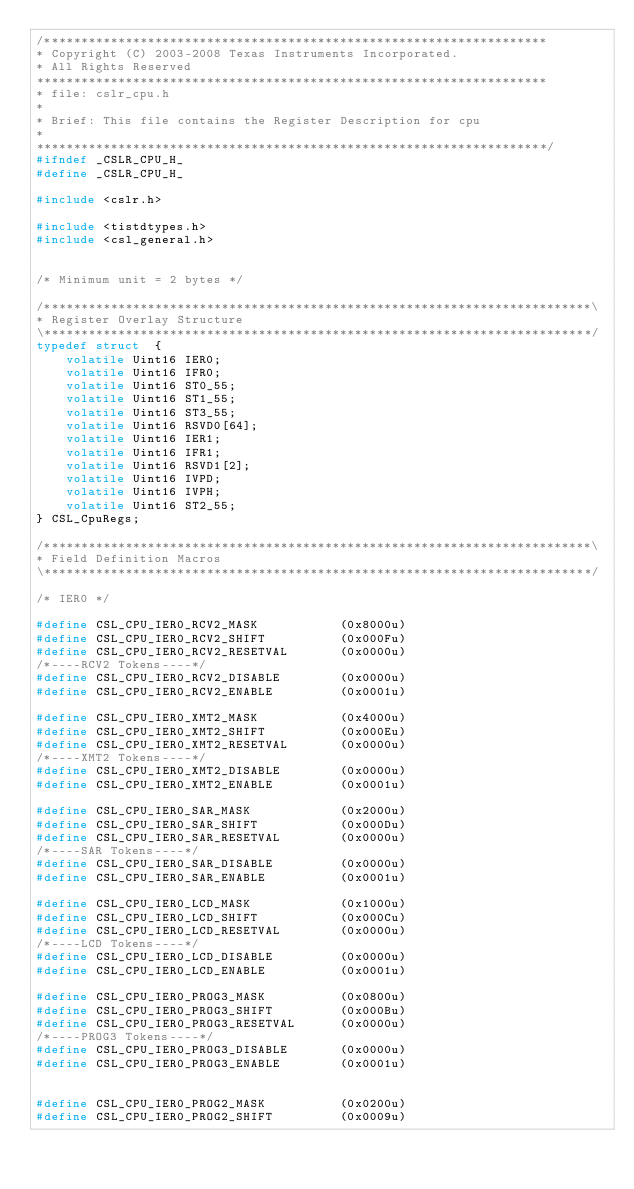Convert code to text. <code><loc_0><loc_0><loc_500><loc_500><_C_>/********************************************************************
* Copyright (C) 2003-2008 Texas Instruments Incorporated.
* All Rights Reserved
*********************************************************************
* file: cslr_cpu.h
*
* Brief: This file contains the Register Description for cpu
*
*********************************************************************/
#ifndef _CSLR_CPU_H_
#define _CSLR_CPU_H_

#include <cslr.h>

#include <tistdtypes.h>
#include <csl_general.h>


/* Minimum unit = 2 bytes */

/**************************************************************************\
* Register Overlay Structure
\**************************************************************************/
typedef struct  {
    volatile Uint16 IER0;
    volatile Uint16 IFR0;
    volatile Uint16 ST0_55;
    volatile Uint16 ST1_55;
    volatile Uint16 ST3_55;
    volatile Uint16 RSVD0[64];
    volatile Uint16 IER1;
    volatile Uint16 IFR1;
    volatile Uint16 RSVD1[2];
    volatile Uint16 IVPD;
    volatile Uint16 IVPH;
    volatile Uint16 ST2_55;
} CSL_CpuRegs;

/**************************************************************************\
* Field Definition Macros
\**************************************************************************/

/* IER0 */

#define CSL_CPU_IER0_RCV2_MASK           (0x8000u)
#define CSL_CPU_IER0_RCV2_SHIFT          (0x000Fu)
#define CSL_CPU_IER0_RCV2_RESETVAL       (0x0000u)
/*----RCV2 Tokens----*/
#define CSL_CPU_IER0_RCV2_DISABLE        (0x0000u)
#define CSL_CPU_IER0_RCV2_ENABLE         (0x0001u)

#define CSL_CPU_IER0_XMT2_MASK           (0x4000u)
#define CSL_CPU_IER0_XMT2_SHIFT          (0x000Eu)
#define CSL_CPU_IER0_XMT2_RESETVAL       (0x0000u)
/*----XMT2 Tokens----*/
#define CSL_CPU_IER0_XMT2_DISABLE        (0x0000u)
#define CSL_CPU_IER0_XMT2_ENABLE         (0x0001u)

#define CSL_CPU_IER0_SAR_MASK            (0x2000u)
#define CSL_CPU_IER0_SAR_SHIFT           (0x000Du)
#define CSL_CPU_IER0_SAR_RESETVAL        (0x0000u)
/*----SAR Tokens----*/
#define CSL_CPU_IER0_SAR_DISABLE         (0x0000u)
#define CSL_CPU_IER0_SAR_ENABLE          (0x0001u)

#define CSL_CPU_IER0_LCD_MASK            (0x1000u)
#define CSL_CPU_IER0_LCD_SHIFT           (0x000Cu)
#define CSL_CPU_IER0_LCD_RESETVAL        (0x0000u)
/*----LCD Tokens----*/
#define CSL_CPU_IER0_LCD_DISABLE         (0x0000u)
#define CSL_CPU_IER0_LCD_ENABLE          (0x0001u)

#define CSL_CPU_IER0_PROG3_MASK          (0x0800u)
#define CSL_CPU_IER0_PROG3_SHIFT         (0x000Bu)
#define CSL_CPU_IER0_PROG3_RESETVAL      (0x0000u)
/*----PROG3 Tokens----*/
#define CSL_CPU_IER0_PROG3_DISABLE       (0x0000u)
#define CSL_CPU_IER0_PROG3_ENABLE        (0x0001u)


#define CSL_CPU_IER0_PROG2_MASK          (0x0200u)
#define CSL_CPU_IER0_PROG2_SHIFT         (0x0009u)</code> 